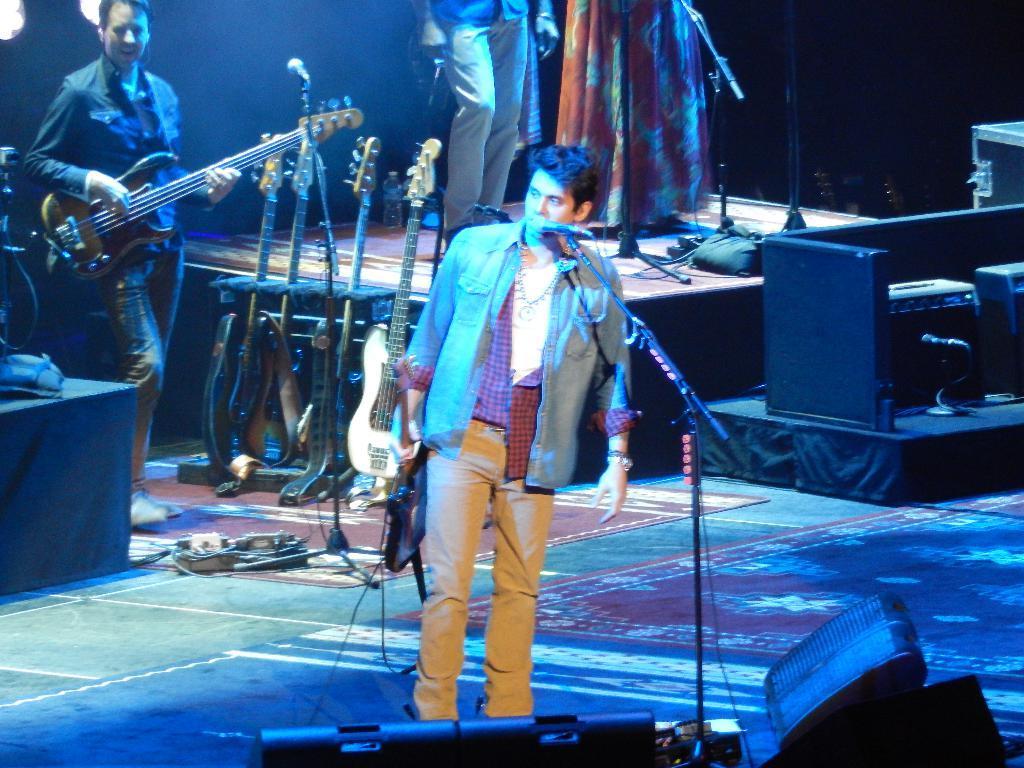Please provide a concise description of this image. A person wearing a shirt is standing holding a guitar and singing. In front of him there is a mic and mic stand. In the back another person is playing guitar. Also there are many guitars on the stands. On the stage there are two persons standing. In the front there are speakers. 